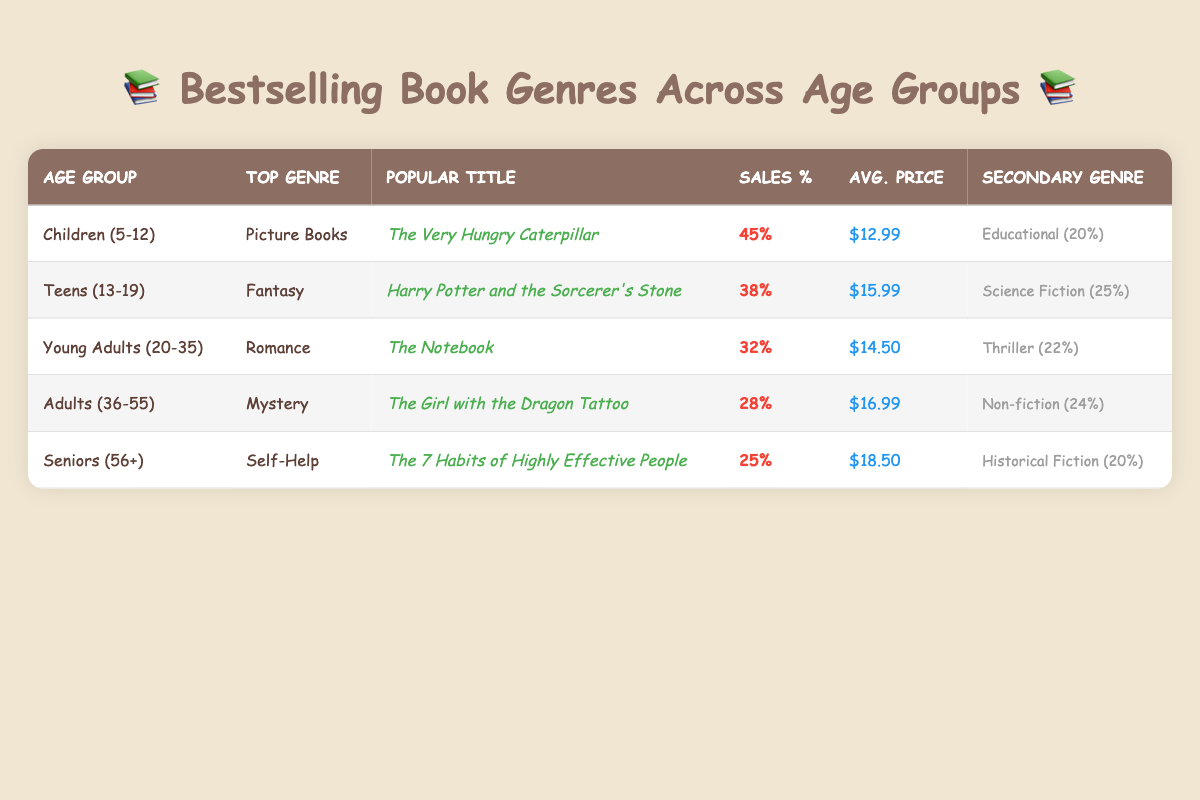What is the top genre for Children aged 5-12? According to the table, the top genre for the Children (5-12) age group is listed as "Picture Books."
Answer: Picture Books Which popular title sells the most in the Teens (13-19) age group? The table indicates that the popular title for the Teens (13-19) age group is "Harry Potter and the Sorcerer's Stone."
Answer: Harry Potter and the Sorcerer's Stone How many percentage of sales does the top genre for Young Adults (20-35) have? The table shows that the top genre for Young Adults (20-35) is "Romance," with a sales percentage of 32%.
Answer: 32% Which age group has the highest sales percentage for bestsellers? By examining the sales percentages in the table, the Children (5-12) age group has the highest sales percentage at 45%.
Answer: Children (5-12) Do Seniors prefer Mystery novels over Self-Help? The table lists "Self-Help" as the top genre for Seniors (56+) with a sales percentage of 25%, while "Mystery" is the top genre for Adults (36-55) with a lower sales percentage of 28%. Therefore, Seniors do not prefer Mystery over Self-Help.
Answer: No What is the total sales percentage for secondary genres among all age groups? First, we add the secondary genre sales percentages: 20% (Children) + 25% (Teens) + 22% (Young Adults) + 24% (Adults) + 20% (Seniors) = 111%. The total sales percentage for secondary genres is 111%.
Answer: 111% Which age group has the lowest average price for bestselling books? By comparing the average prices from each age group listed in the table, Young Adults (20-35) have the lowest average price at $14.50.
Answer: Young Adults (20-35) Is Romance the top genre across all listed age groups? No, the table shows that Romance is the top genre for Young Adults (20-35) but not for the other age groups, which have different top genres.
Answer: No What is the difference in sales percentage between the top genres of Children (5-12) and Seniors (56+)? The sales percentage for the top genre of Children (5-12) is 45% while for Seniors (56+) it is 25%. The difference can be calculated as 45% - 25% = 20%.
Answer: 20% 